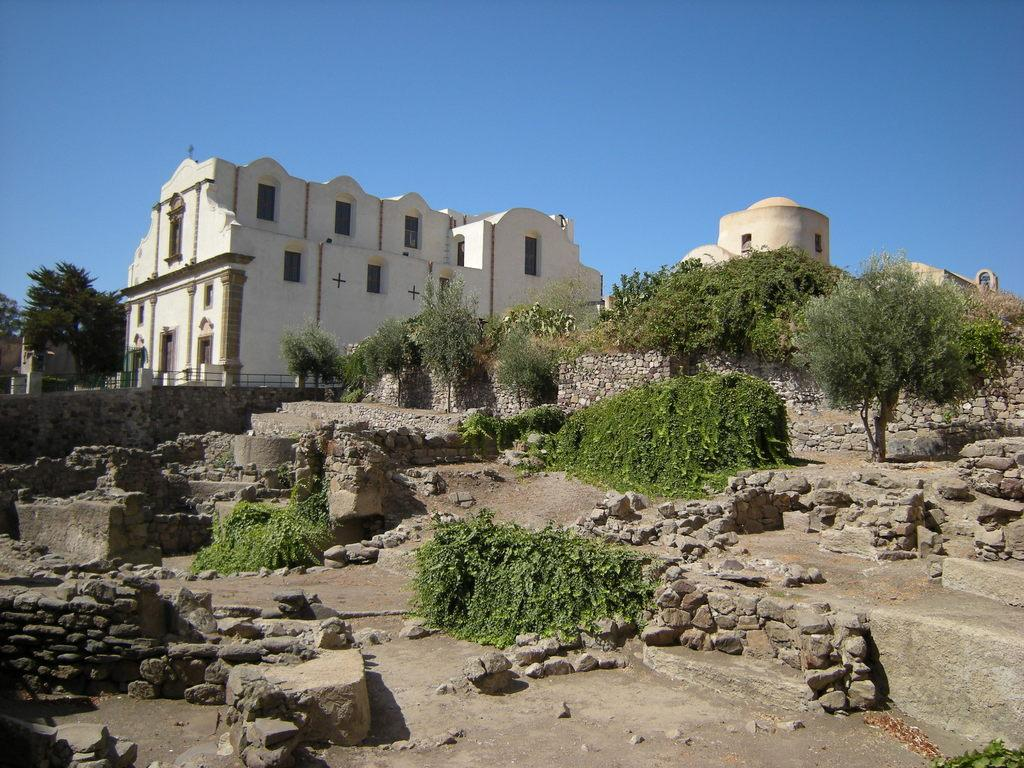What type of natural elements can be seen in the image? There are rocks and trees in the image. What type of man-made structures are present in the image? There are buildings in the image. What type of fruit is growing on the rocks in the image? There is no fruit growing on the rocks in the image; only rocks and trees are present. What type of mine can be seen in the image? There is no mine present in the image; it features rocks, trees, and buildings. 